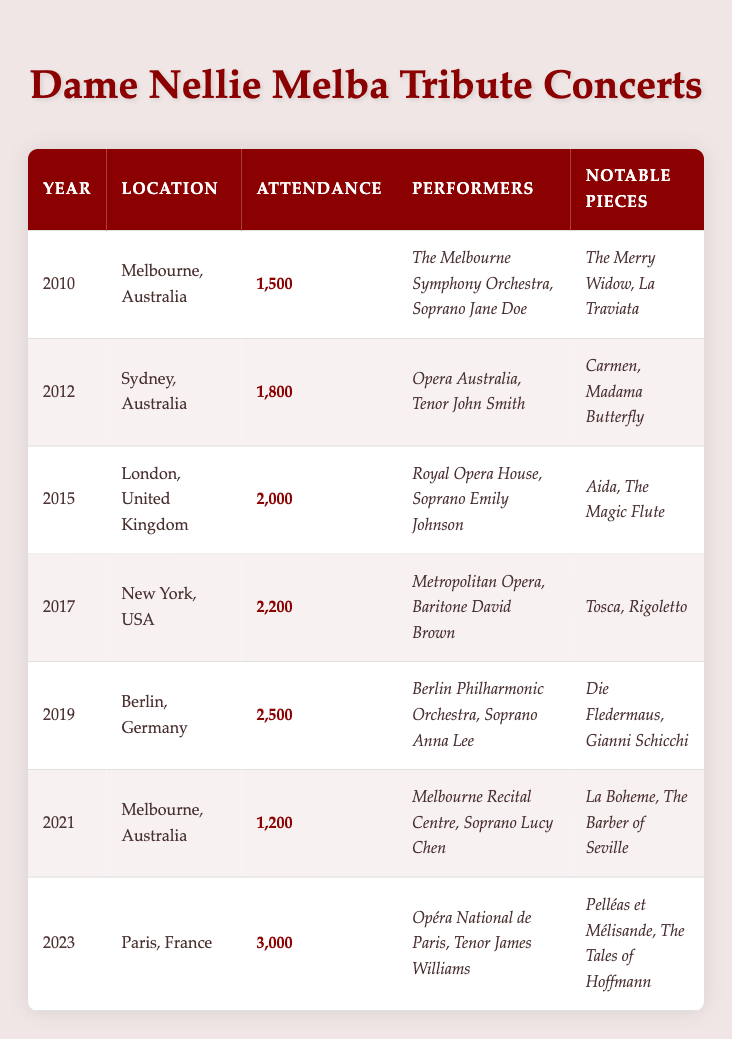What was the attendance at the 2021 tribute concert? The table indicates that the attendance for the 2021 tribute concert held in Melbourne, Australia was 1,200.
Answer: 1,200 Which location had the highest attendance for a tribute concert? By examining the attendance figures in the table, the highest attendance was at the Paris concert in 2023, with 3,000 attendees.
Answer: 3,000 In which year did the tribute concert in London take place? The table shows that the tribute concert in London, United Kingdom, was held in 2015.
Answer: 2015 What are the notable pieces performed at the 2019 concert? The table lists "Die Fledermaus" and "Gianni Schicchi" as the notable pieces performed at the Berlin concert in 2019.
Answer: Die Fledermaus, Gianni Schicchi How many more attendees were there in 2023 compared to 2010? First, find the attendance for 2023, which is 3,000, then for 2010, which is 1,500. The difference is 3,000 - 1,500 = 1,500.
Answer: 1,500 Was the attendance in 2021 higher than that in 2017? The attendance in 2021 was 1,200, while in 2017 it was 2,200. Since 1,200 is less than 2,200, the statement is false.
Answer: No What is the average attendance from 2010 to 2023? Sum the attendances: 1,500 + 1,800 + 2,000 + 2,200 + 2,500 + 1,200 + 3,000 = 14,200. Then divide by the number of concerts, which is 7: 14,200 / 7 = 2,028.57.
Answer: 2,028.57 Which soprano performed at the tribute concert in New York? The table indicates that the baritone David Brown performed at the New York concert in 2017; there was no soprano listed for that event. The question needs to specify if it is looking for a particular performer identified as a soprano.
Answer: No soprano How many tribute concerts were held in Australia? The table shows that there were three concerts held in Australia: one in Melbourne in 2010, one in Sydney in 2012, and another in Melbourne in 2021.
Answer: 3 What was the attendance trend from 2010 to 2023? By comparing the attendance numbers, we can see an overall increase from 1,500 in 2010 to 3,000 in 2023, demonstrating a positive trend over the years.
Answer: Increasing 